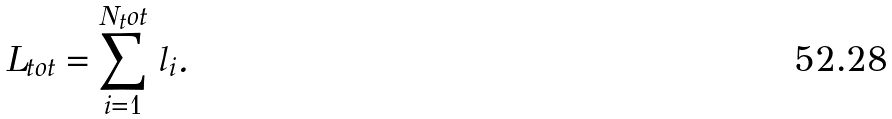Convert formula to latex. <formula><loc_0><loc_0><loc_500><loc_500>L _ { t o t } = \sum _ { i = 1 } ^ { N { _ { t } o t } } \, l _ { i } .</formula> 